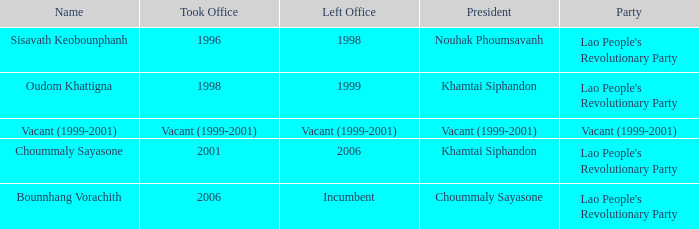What is Party, when Name is Oudom Khattigna? Lao People's Revolutionary Party. 